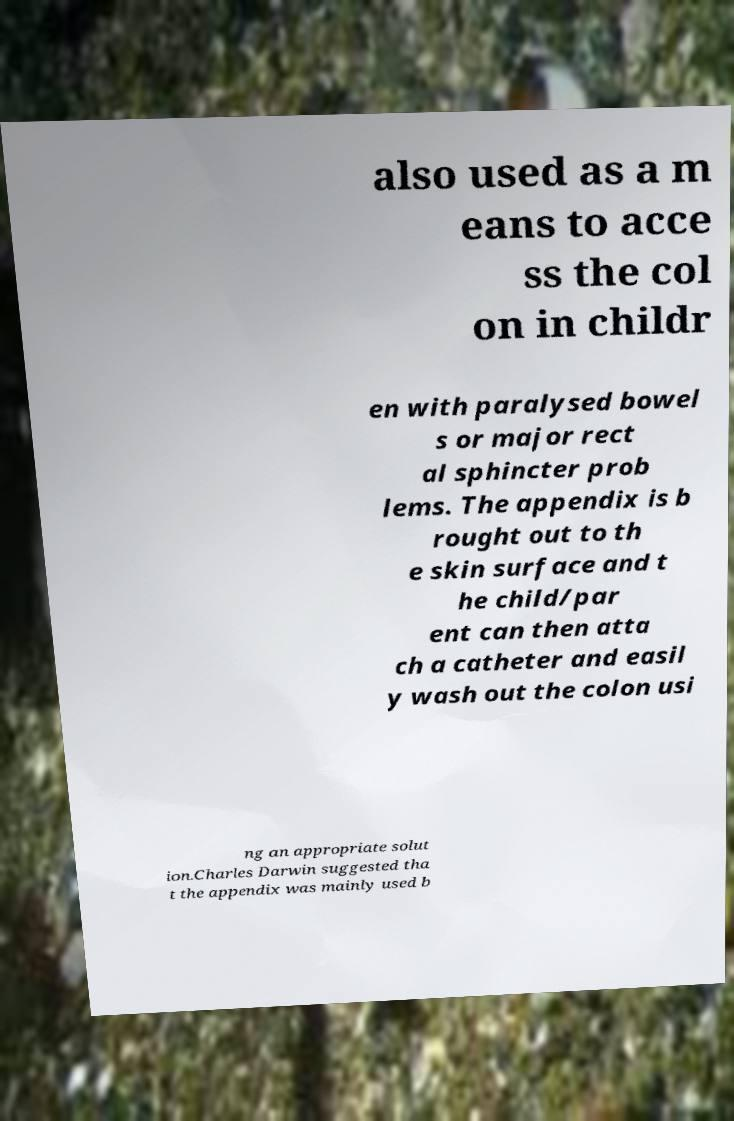For documentation purposes, I need the text within this image transcribed. Could you provide that? also used as a m eans to acce ss the col on in childr en with paralysed bowel s or major rect al sphincter prob lems. The appendix is b rought out to th e skin surface and t he child/par ent can then atta ch a catheter and easil y wash out the colon usi ng an appropriate solut ion.Charles Darwin suggested tha t the appendix was mainly used b 